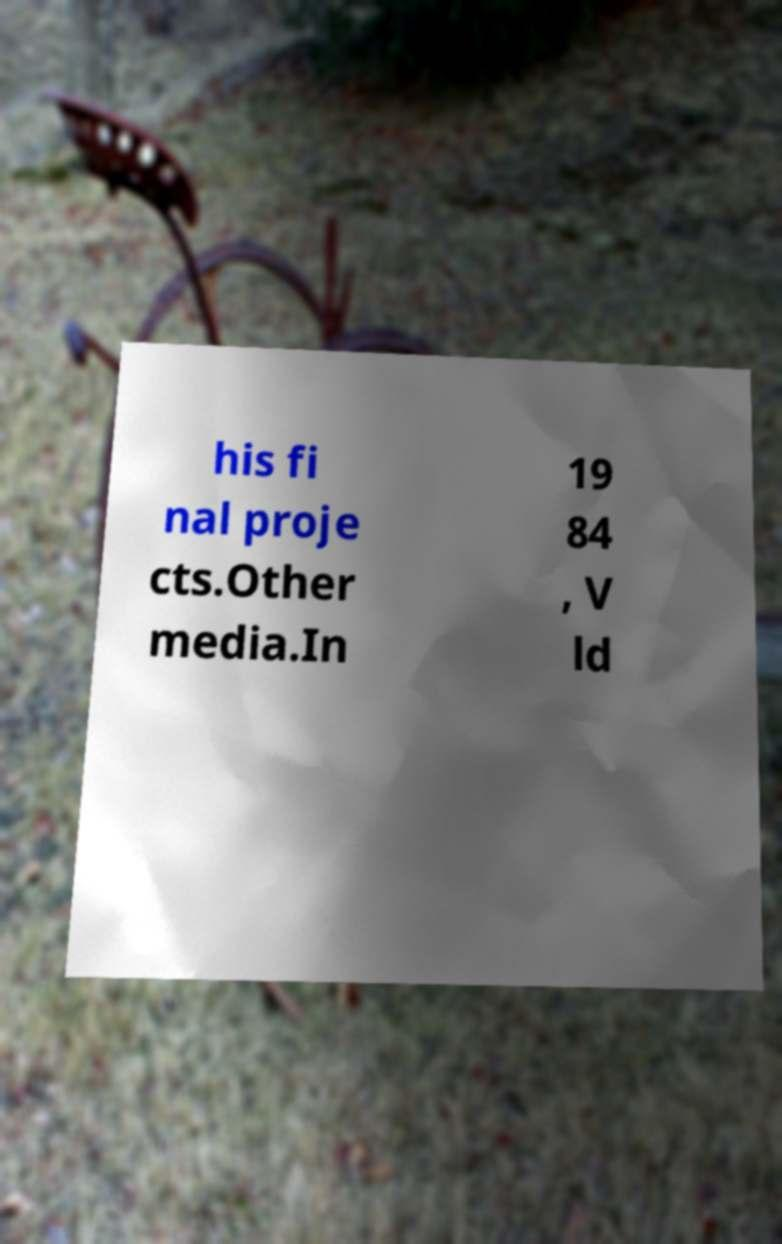Could you extract and type out the text from this image? his fi nal proje cts.Other media.In 19 84 , V ld 